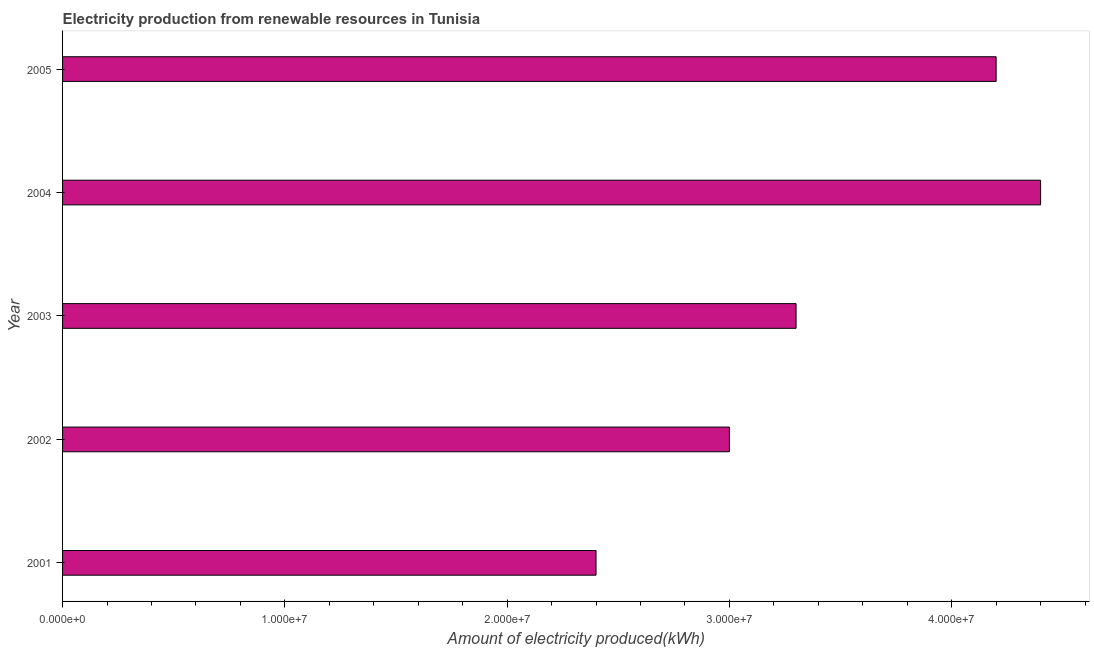Does the graph contain any zero values?
Offer a very short reply. No. What is the title of the graph?
Ensure brevity in your answer.  Electricity production from renewable resources in Tunisia. What is the label or title of the X-axis?
Provide a succinct answer. Amount of electricity produced(kWh). What is the amount of electricity produced in 2001?
Make the answer very short. 2.40e+07. Across all years, what is the maximum amount of electricity produced?
Keep it short and to the point. 4.40e+07. Across all years, what is the minimum amount of electricity produced?
Give a very brief answer. 2.40e+07. In which year was the amount of electricity produced maximum?
Give a very brief answer. 2004. What is the sum of the amount of electricity produced?
Keep it short and to the point. 1.73e+08. What is the difference between the amount of electricity produced in 2001 and 2003?
Your answer should be very brief. -9.00e+06. What is the average amount of electricity produced per year?
Your answer should be compact. 3.46e+07. What is the median amount of electricity produced?
Your answer should be very brief. 3.30e+07. In how many years, is the amount of electricity produced greater than 34000000 kWh?
Your answer should be compact. 2. Do a majority of the years between 2004 and 2005 (inclusive) have amount of electricity produced greater than 14000000 kWh?
Your answer should be very brief. Yes. What is the ratio of the amount of electricity produced in 2001 to that in 2003?
Provide a succinct answer. 0.73. Is the amount of electricity produced in 2003 less than that in 2004?
Offer a very short reply. Yes. Is the difference between the amount of electricity produced in 2001 and 2002 greater than the difference between any two years?
Make the answer very short. No. What is the difference between the highest and the second highest amount of electricity produced?
Keep it short and to the point. 2.00e+06. What is the difference between the highest and the lowest amount of electricity produced?
Ensure brevity in your answer.  2.00e+07. In how many years, is the amount of electricity produced greater than the average amount of electricity produced taken over all years?
Give a very brief answer. 2. How many bars are there?
Your response must be concise. 5. Are all the bars in the graph horizontal?
Offer a terse response. Yes. How many years are there in the graph?
Offer a terse response. 5. Are the values on the major ticks of X-axis written in scientific E-notation?
Make the answer very short. Yes. What is the Amount of electricity produced(kWh) in 2001?
Your answer should be compact. 2.40e+07. What is the Amount of electricity produced(kWh) in 2002?
Your response must be concise. 3.00e+07. What is the Amount of electricity produced(kWh) in 2003?
Your answer should be compact. 3.30e+07. What is the Amount of electricity produced(kWh) in 2004?
Give a very brief answer. 4.40e+07. What is the Amount of electricity produced(kWh) of 2005?
Your response must be concise. 4.20e+07. What is the difference between the Amount of electricity produced(kWh) in 2001 and 2002?
Offer a terse response. -6.00e+06. What is the difference between the Amount of electricity produced(kWh) in 2001 and 2003?
Offer a very short reply. -9.00e+06. What is the difference between the Amount of electricity produced(kWh) in 2001 and 2004?
Offer a terse response. -2.00e+07. What is the difference between the Amount of electricity produced(kWh) in 2001 and 2005?
Your answer should be compact. -1.80e+07. What is the difference between the Amount of electricity produced(kWh) in 2002 and 2003?
Offer a very short reply. -3.00e+06. What is the difference between the Amount of electricity produced(kWh) in 2002 and 2004?
Offer a very short reply. -1.40e+07. What is the difference between the Amount of electricity produced(kWh) in 2002 and 2005?
Keep it short and to the point. -1.20e+07. What is the difference between the Amount of electricity produced(kWh) in 2003 and 2004?
Keep it short and to the point. -1.10e+07. What is the difference between the Amount of electricity produced(kWh) in 2003 and 2005?
Provide a short and direct response. -9.00e+06. What is the difference between the Amount of electricity produced(kWh) in 2004 and 2005?
Ensure brevity in your answer.  2.00e+06. What is the ratio of the Amount of electricity produced(kWh) in 2001 to that in 2002?
Keep it short and to the point. 0.8. What is the ratio of the Amount of electricity produced(kWh) in 2001 to that in 2003?
Offer a terse response. 0.73. What is the ratio of the Amount of electricity produced(kWh) in 2001 to that in 2004?
Ensure brevity in your answer.  0.55. What is the ratio of the Amount of electricity produced(kWh) in 2001 to that in 2005?
Make the answer very short. 0.57. What is the ratio of the Amount of electricity produced(kWh) in 2002 to that in 2003?
Offer a very short reply. 0.91. What is the ratio of the Amount of electricity produced(kWh) in 2002 to that in 2004?
Provide a succinct answer. 0.68. What is the ratio of the Amount of electricity produced(kWh) in 2002 to that in 2005?
Your answer should be very brief. 0.71. What is the ratio of the Amount of electricity produced(kWh) in 2003 to that in 2004?
Make the answer very short. 0.75. What is the ratio of the Amount of electricity produced(kWh) in 2003 to that in 2005?
Offer a very short reply. 0.79. What is the ratio of the Amount of electricity produced(kWh) in 2004 to that in 2005?
Your response must be concise. 1.05. 